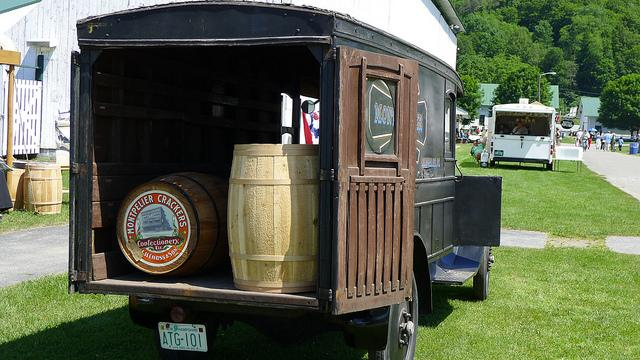What type of labeling is on the barrel? montpellier crackers 